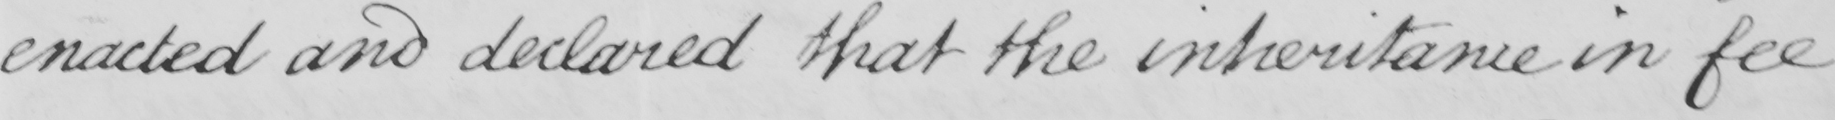What does this handwritten line say? enacted and declared that the inheritance in fee 